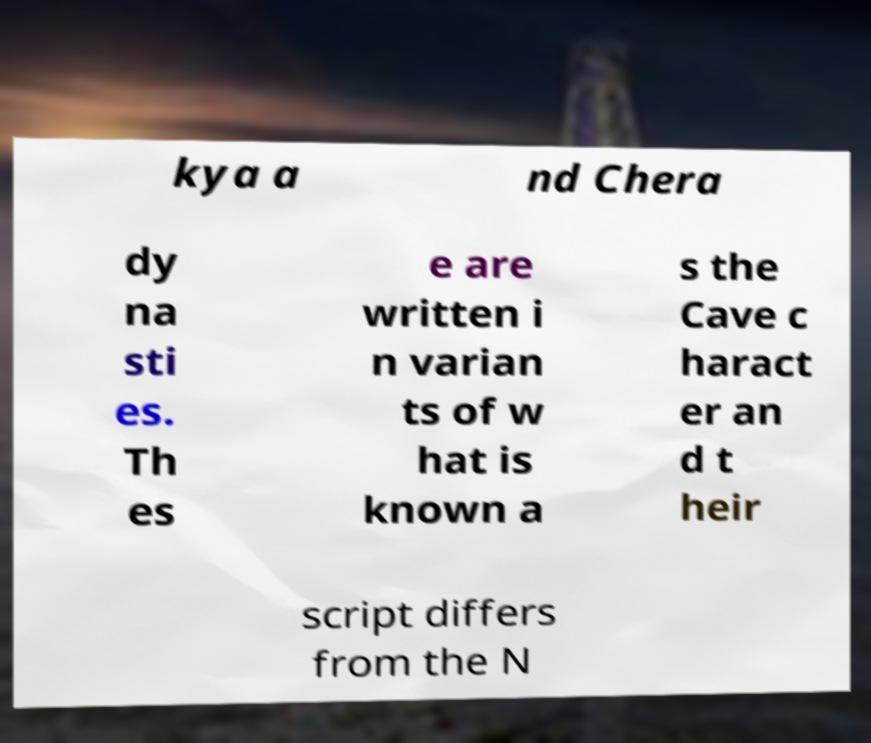Please identify and transcribe the text found in this image. kya a nd Chera dy na sti es. Th es e are written i n varian ts of w hat is known a s the Cave c haract er an d t heir script differs from the N 